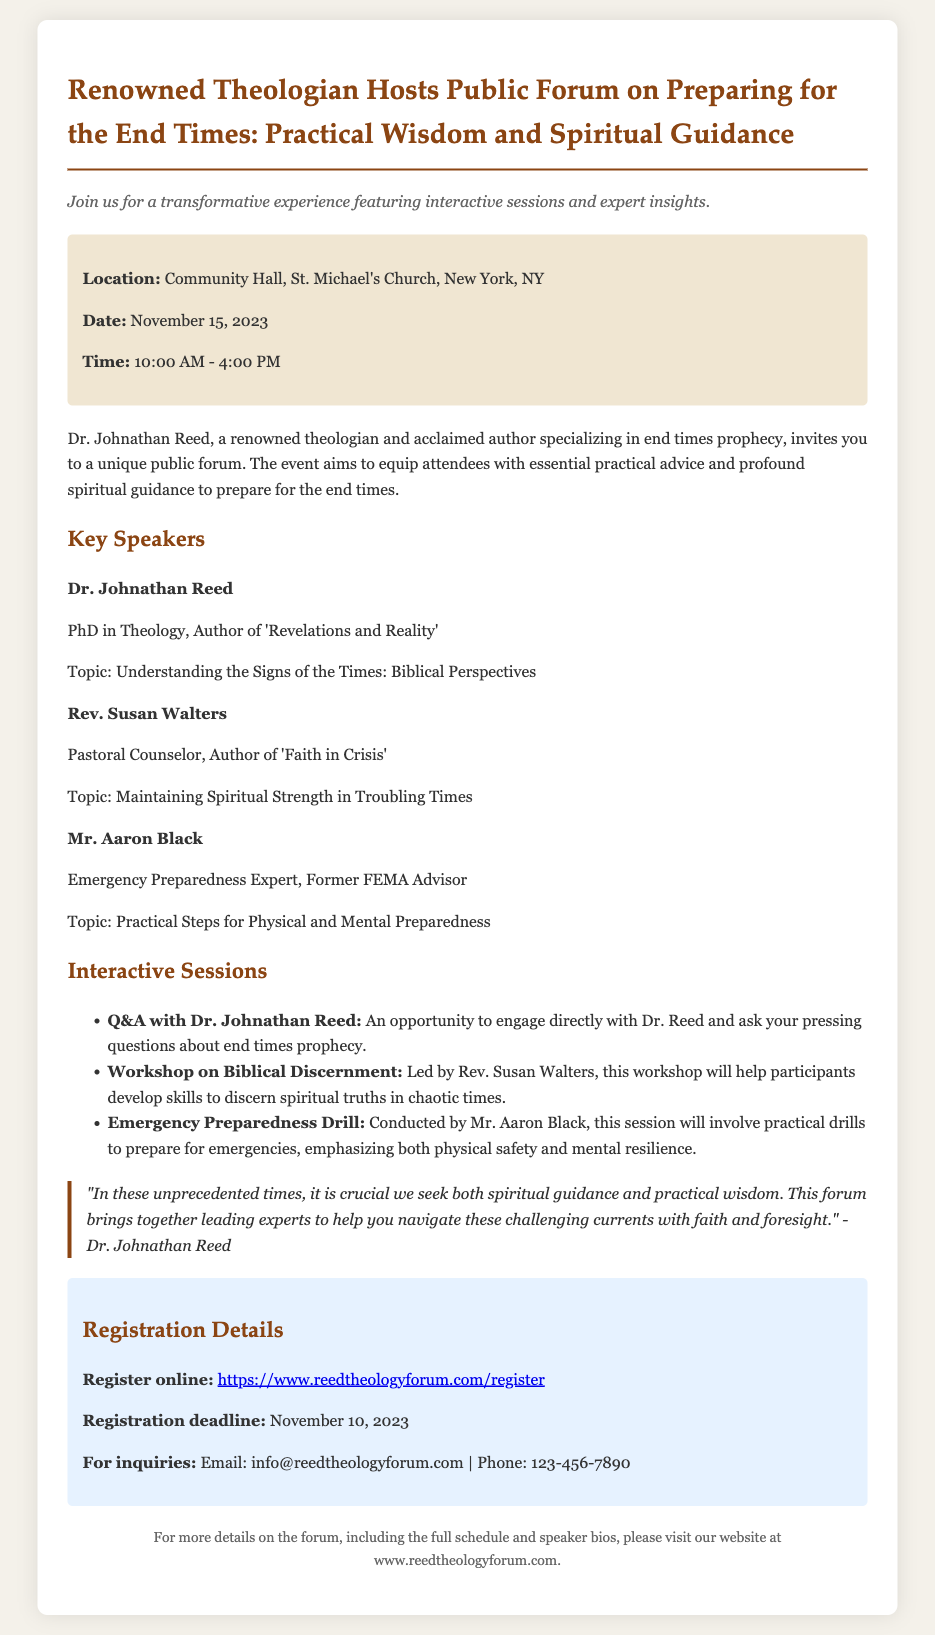What is the title of the forum? The title of the forum is explicitly mentioned in the document.
Answer: Preparing for the End Times: Practical Wisdom and Spiritual Guidance Who is the main speaker at the forum? The main speaker is highlighted in the document as a key figure.
Answer: Dr. Johnathan Reed What is the location of the event? The document clearly states where the forum will take place.
Answer: Community Hall, St. Michael's Church, New York, NY When is the registration deadline? The registration deadline is specified in the registration details section of the document.
Answer: November 10, 2023 What time does the forum start? The starting time of the forum is provided in the event details section.
Answer: 10:00 AM Which workshop is led by Rev. Susan Walters? The document lists the topics of various interactive sessions, including the one led by Rev. Walters.
Answer: Workshop on Biblical Discernment What is the purpose of the forum? The purpose of the forum is articulated in the introduction of the document.
Answer: To equip attendees with essential practical advice and profound spiritual guidance What type of expert is Mr. Aaron Black? The document categorizes Mr. Black's profession.
Answer: Emergency Preparedness Expert 